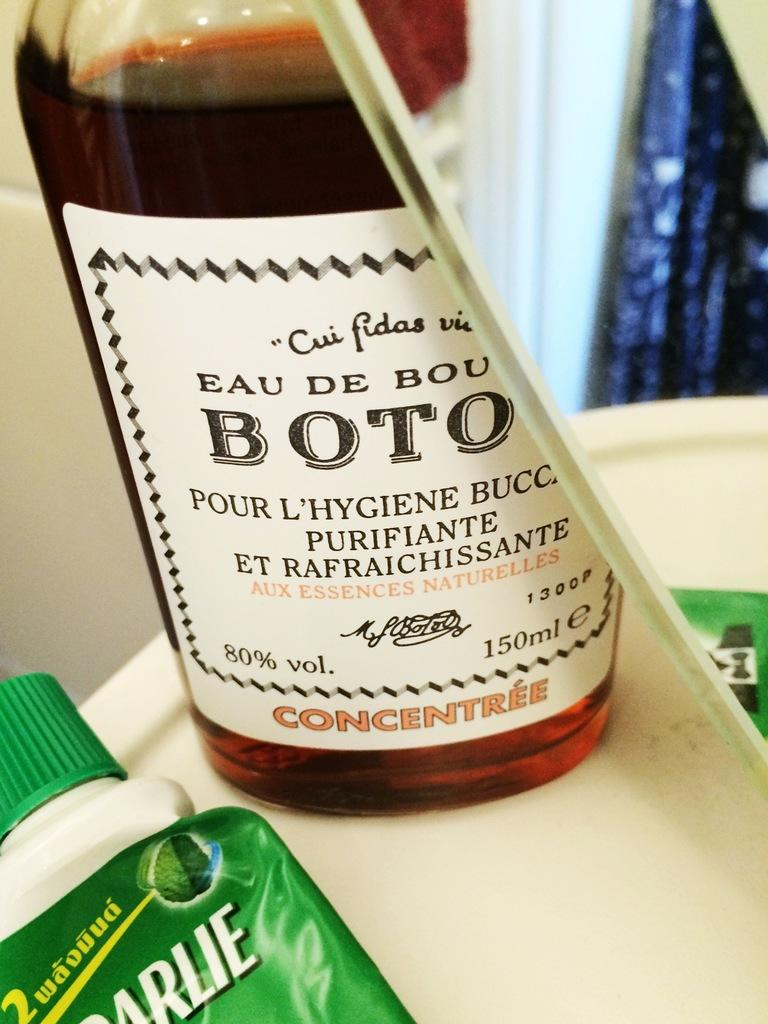<image>
Provide a brief description of the given image. A glass bottle of Boto Concentree dark colored liquid 